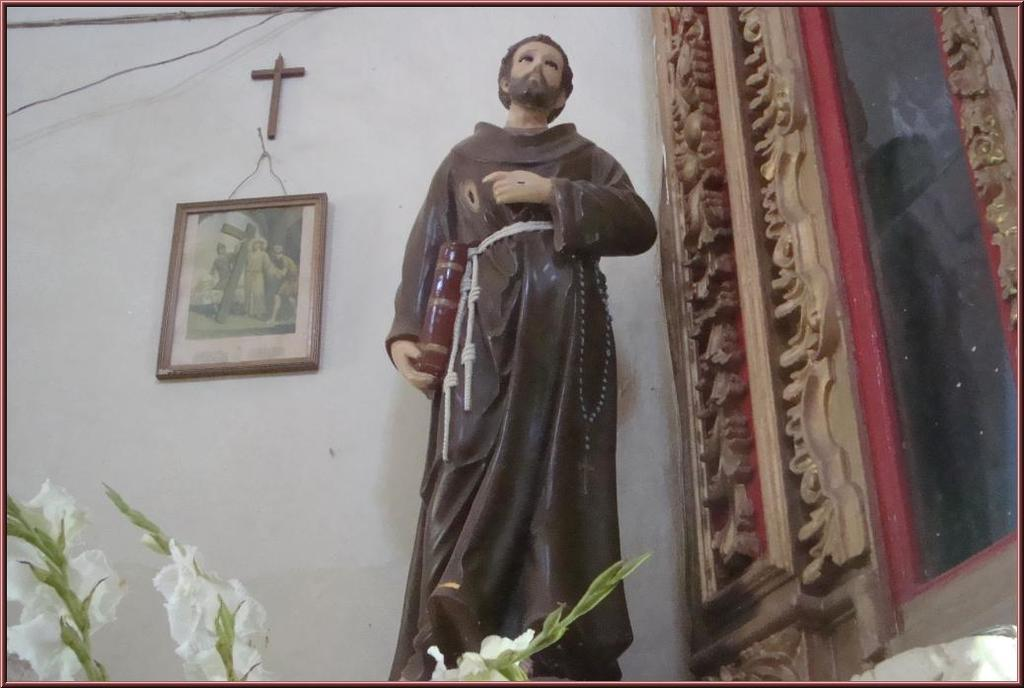What is the main object in the image? There is a statue in the image. What is located beside the statue? There is a photo frame beside the statue. What religious symbol can be seen in the image? There is a cross hanging on the wall in the image. What type of plant is present at the bottom of the image? There is a flower plant at the bottom of the image. What color is the cushion on the statue's head in the image? There is no cushion present on the statue's head in the image. 